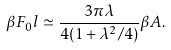<formula> <loc_0><loc_0><loc_500><loc_500>\beta F _ { 0 } l \simeq \frac { 3 \pi \lambda } { 4 ( 1 + \lambda ^ { 2 } / 4 ) } \beta A .</formula> 